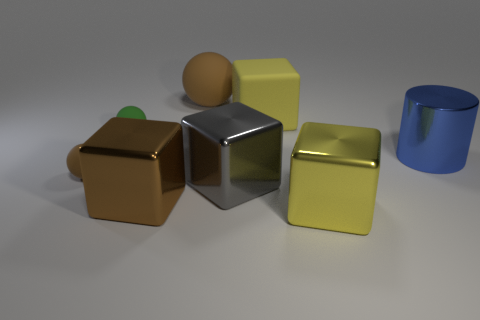Is there anything else that has the same color as the big rubber sphere?
Give a very brief answer. Yes. The green sphere that is made of the same material as the tiny brown ball is what size?
Give a very brief answer. Small. What is the shape of the rubber object that is the same color as the big ball?
Keep it short and to the point. Sphere. What size is the cube that is the same color as the big ball?
Keep it short and to the point. Large. Does the sphere to the right of the brown metal object have the same size as the tiny green rubber sphere?
Give a very brief answer. No. What shape is the big yellow object that is behind the large gray metal block?
Ensure brevity in your answer.  Cube. Are there more large blue cylinders than tiny red matte cubes?
Your response must be concise. Yes. Do the object in front of the big brown metallic cube and the rubber cube have the same color?
Offer a very short reply. Yes. How many objects are objects that are behind the big yellow shiny cube or things behind the shiny cylinder?
Provide a succinct answer. 7. What number of objects are behind the gray block and right of the small brown rubber thing?
Make the answer very short. 4. 